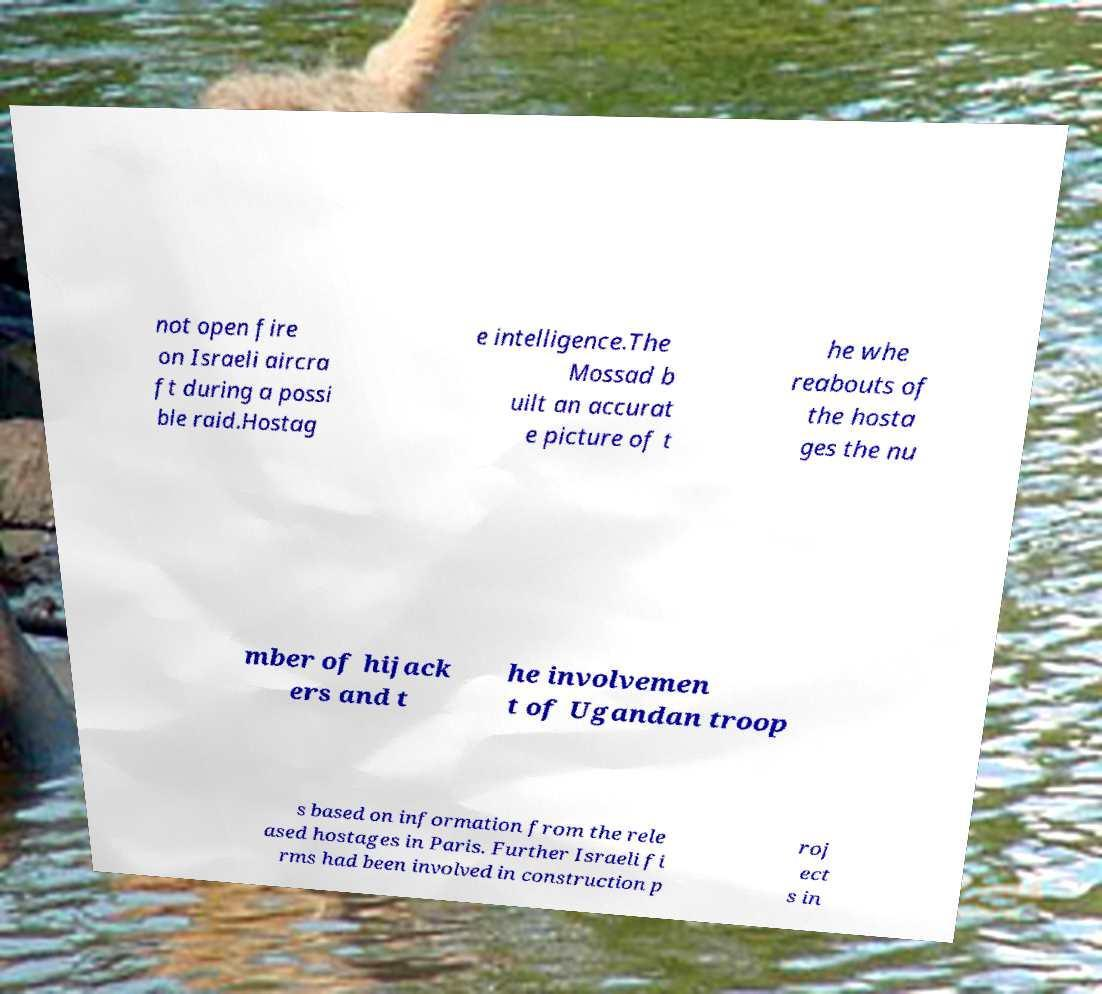I need the written content from this picture converted into text. Can you do that? not open fire on Israeli aircra ft during a possi ble raid.Hostag e intelligence.The Mossad b uilt an accurat e picture of t he whe reabouts of the hosta ges the nu mber of hijack ers and t he involvemen t of Ugandan troop s based on information from the rele ased hostages in Paris. Further Israeli fi rms had been involved in construction p roj ect s in 